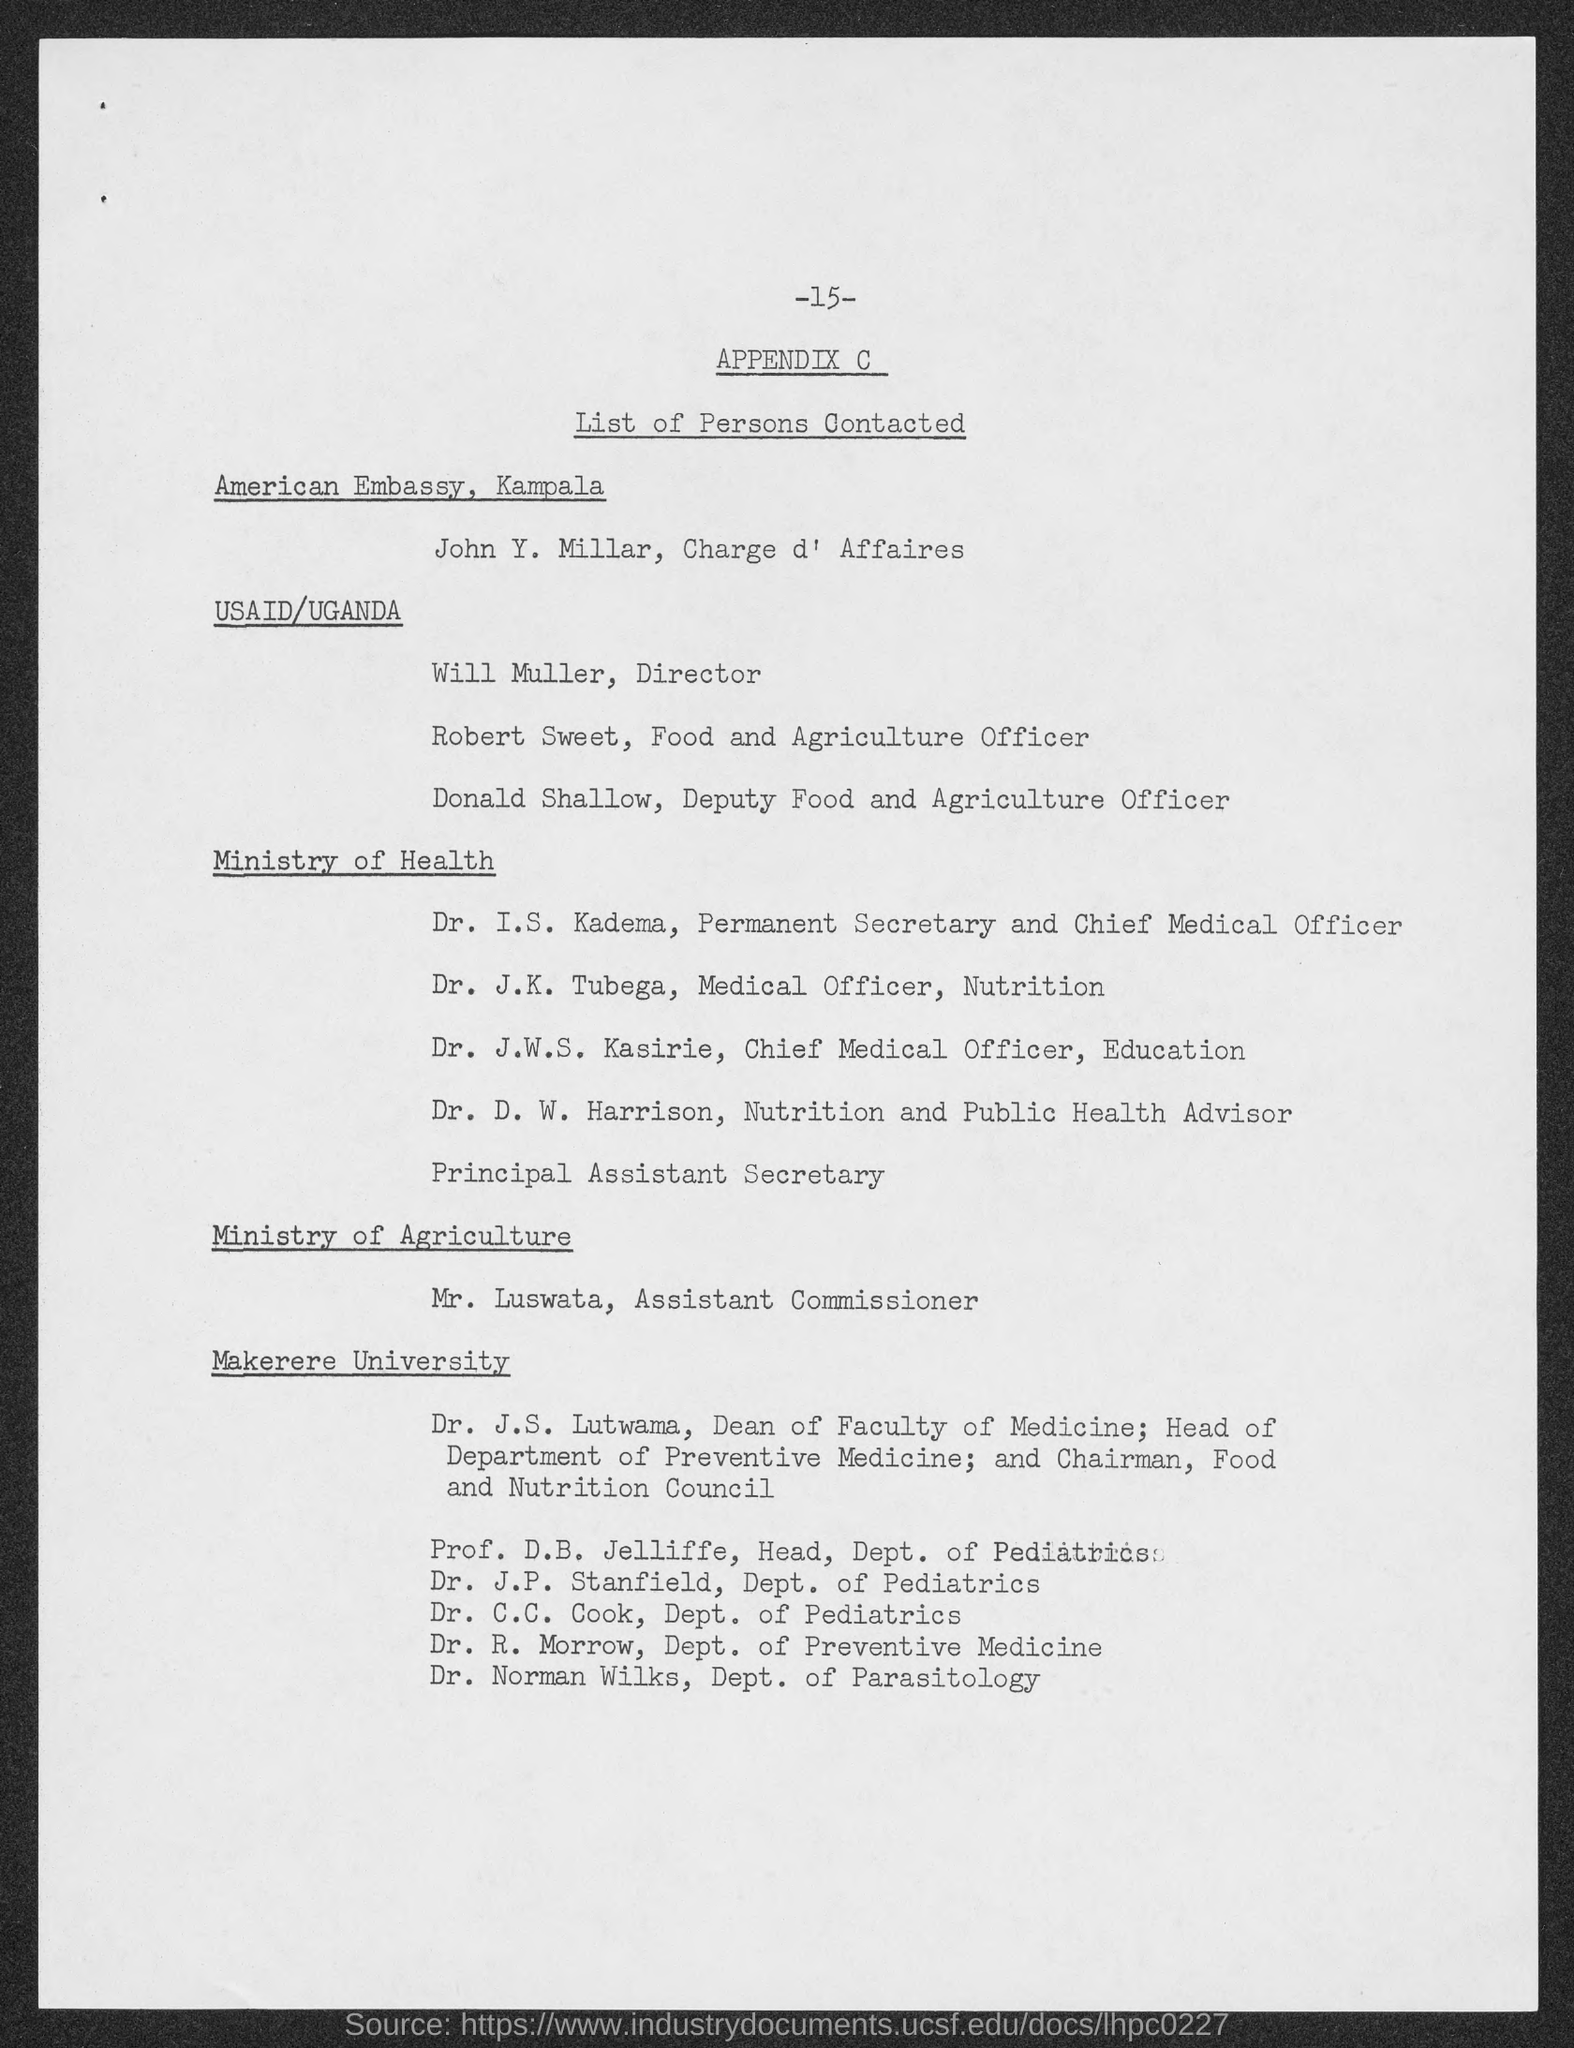Indicate a few pertinent items in this graphic. John Y. Millar is from the American Embassy in Kampala. Donald Shallow is from the United States of America, as well as Uganda, where he received aid from the USAID organization. Dr. J.W.S. Kasirie is from the Ministry of Health. Where is Robert Sweet from? He is from the United States of America and Uganda, as indicated by the USAID/Uganda tag. Mr. Luswata is from the Ministry of Agriculture. 